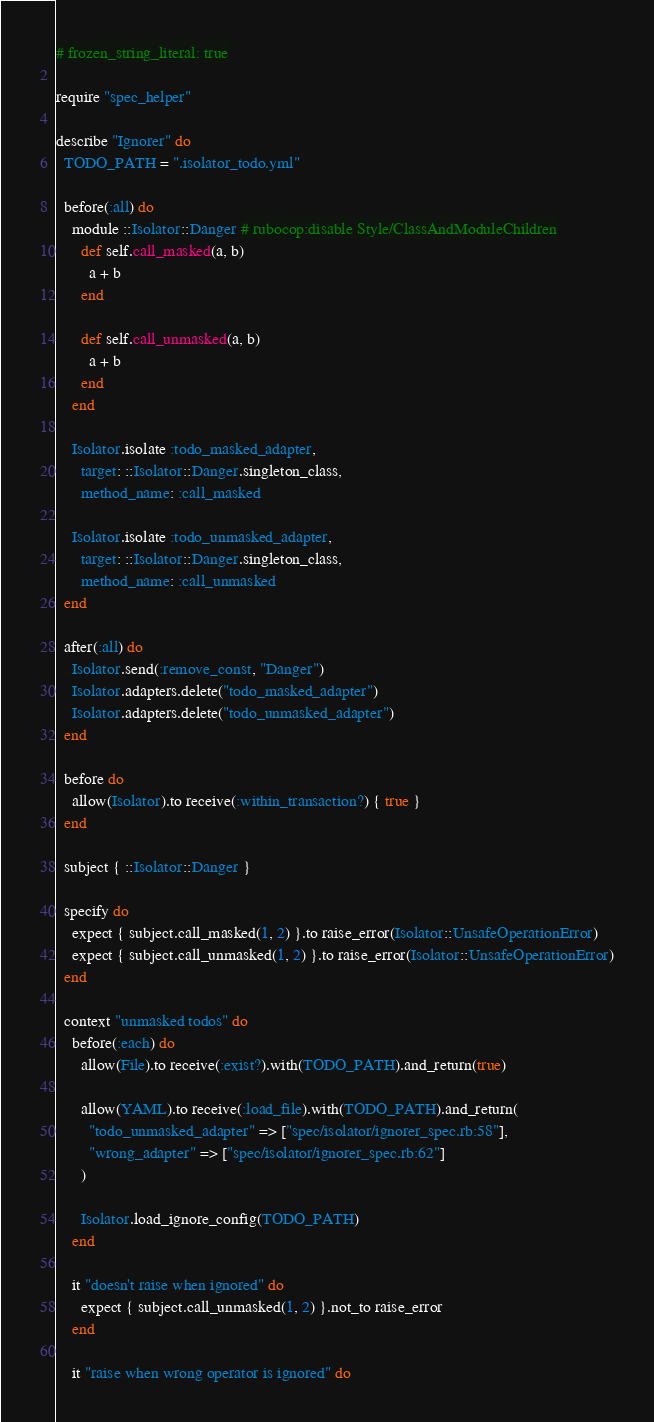Convert code to text. <code><loc_0><loc_0><loc_500><loc_500><_Ruby_># frozen_string_literal: true

require "spec_helper"

describe "Ignorer" do
  TODO_PATH = ".isolator_todo.yml"

  before(:all) do
    module ::Isolator::Danger # rubocop:disable Style/ClassAndModuleChildren
      def self.call_masked(a, b)
        a + b
      end

      def self.call_unmasked(a, b)
        a + b
      end
    end

    Isolator.isolate :todo_masked_adapter,
      target: ::Isolator::Danger.singleton_class,
      method_name: :call_masked

    Isolator.isolate :todo_unmasked_adapter,
      target: ::Isolator::Danger.singleton_class,
      method_name: :call_unmasked
  end

  after(:all) do
    Isolator.send(:remove_const, "Danger")
    Isolator.adapters.delete("todo_masked_adapter")
    Isolator.adapters.delete("todo_unmasked_adapter")
  end

  before do
    allow(Isolator).to receive(:within_transaction?) { true }
  end

  subject { ::Isolator::Danger }

  specify do
    expect { subject.call_masked(1, 2) }.to raise_error(Isolator::UnsafeOperationError)
    expect { subject.call_unmasked(1, 2) }.to raise_error(Isolator::UnsafeOperationError)
  end

  context "unmasked todos" do
    before(:each) do
      allow(File).to receive(:exist?).with(TODO_PATH).and_return(true)

      allow(YAML).to receive(:load_file).with(TODO_PATH).and_return(
        "todo_unmasked_adapter" => ["spec/isolator/ignorer_spec.rb:58"],
        "wrong_adapter" => ["spec/isolator/ignorer_spec.rb:62"]
      )

      Isolator.load_ignore_config(TODO_PATH)
    end

    it "doesn't raise when ignored" do
      expect { subject.call_unmasked(1, 2) }.not_to raise_error
    end

    it "raise when wrong operator is ignored" do</code> 